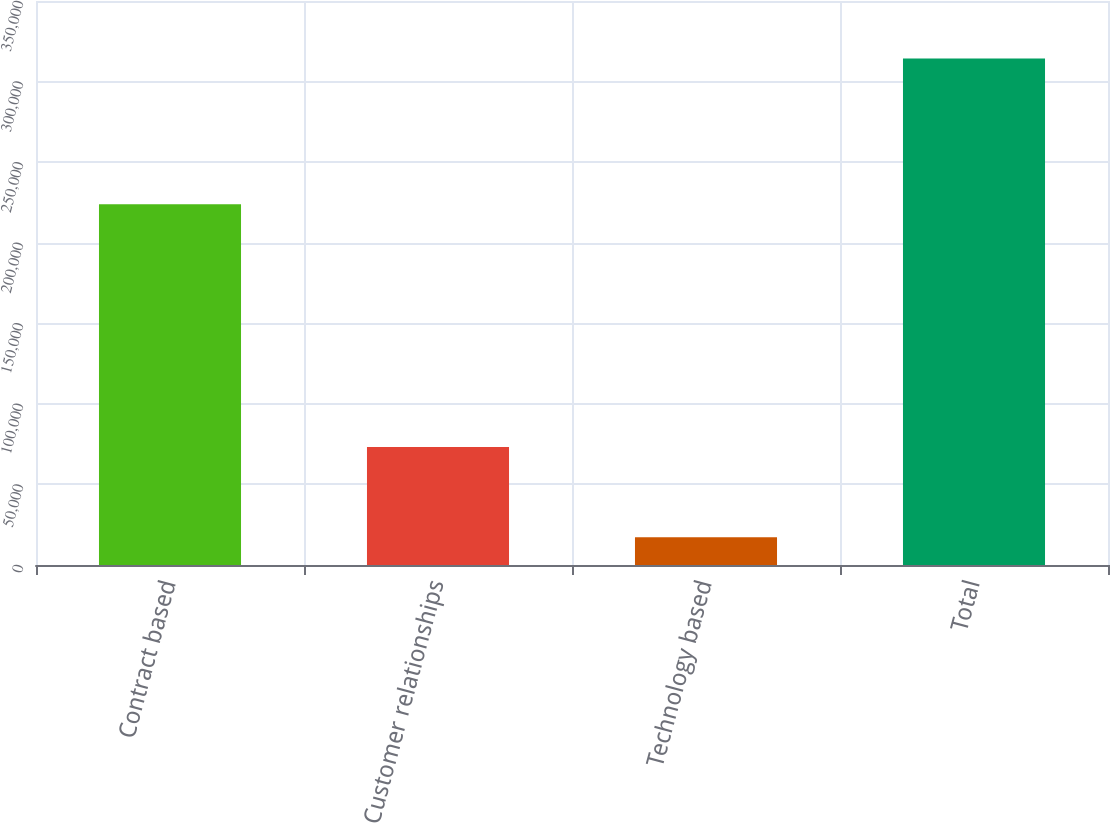Convert chart. <chart><loc_0><loc_0><loc_500><loc_500><bar_chart><fcel>Contract based<fcel>Customer relationships<fcel>Technology based<fcel>Total<nl><fcel>223873<fcel>73298<fcel>17181<fcel>314352<nl></chart> 